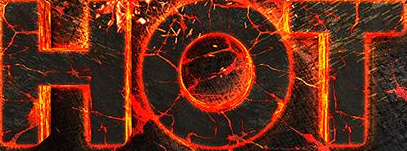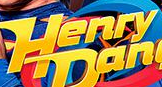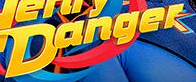What text appears in these images from left to right, separated by a semicolon? HOT; Henry; Danger 